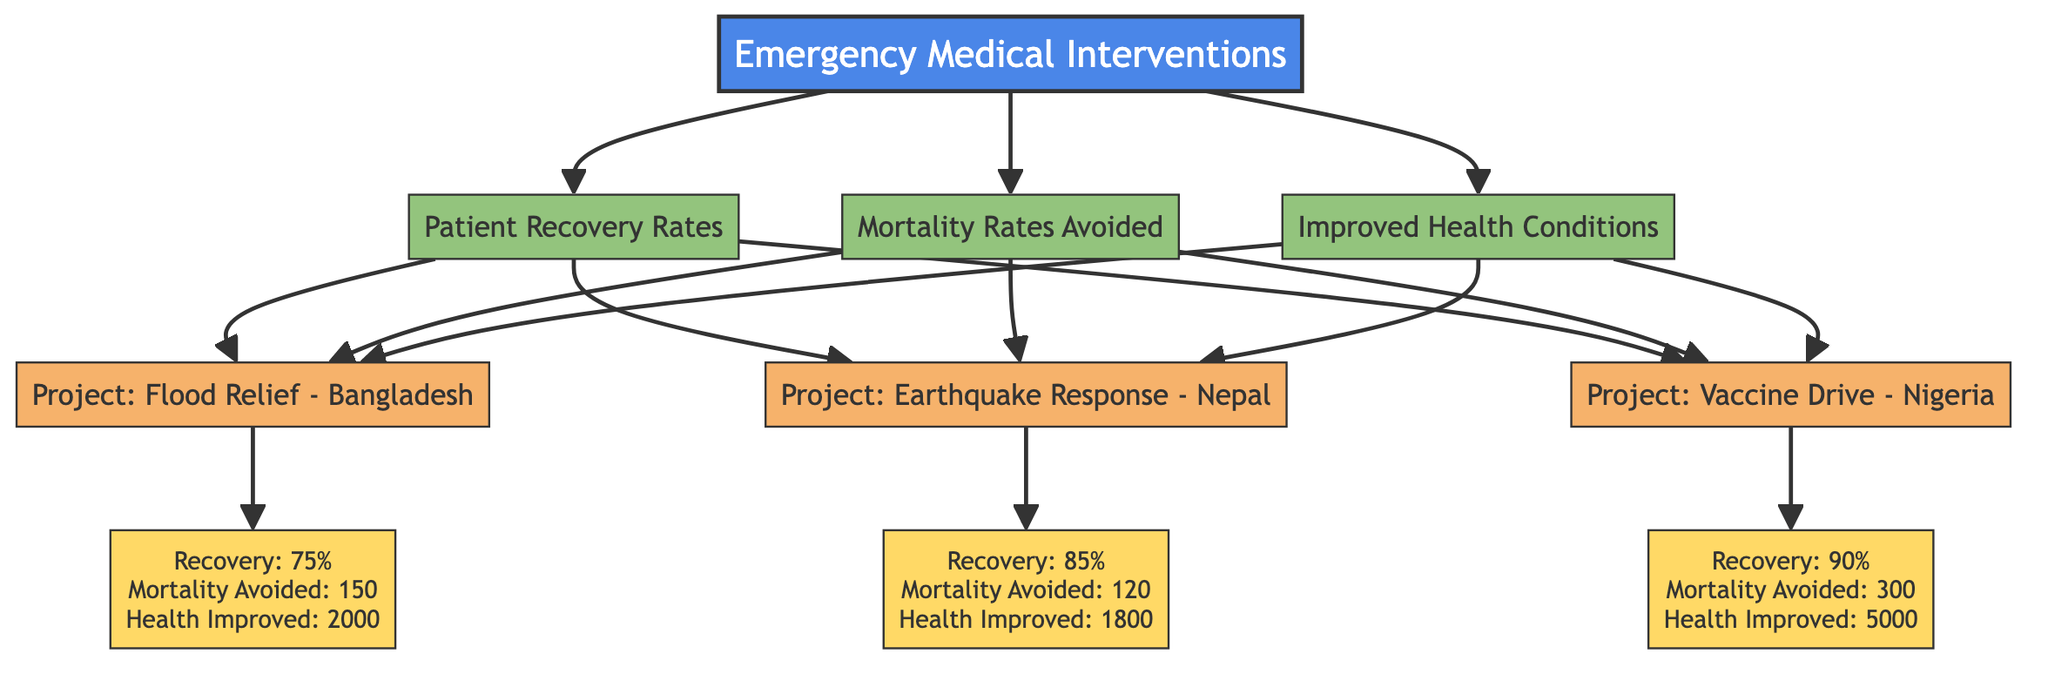What is the recovery rate for the Flood Relief project in Bangladesh? The diagram indicates that the recovery rate for the Flood Relief project in Bangladesh is 75%.
Answer: 75% How many health improvements were reported in the Vaccine Drive project in Nigeria? According to the data in the diagram, there were 5000 health improvements reported in the Vaccine Drive project in Nigeria.
Answer: 5000 What is the mortality rate avoided in the Earthquake Response project in Nepal? The diagram specifies that the mortality rate avoided in the Earthquake Response project in Nepal is 120.
Answer: 120 Which project has the highest patient recovery rate? By comparing the recovery rates indicated in the diagram, the Vaccine Drive project in Nigeria has the highest patient recovery rate at 90%.
Answer: Vaccine Drive - Nigeria How many total projects are represented in the diagram? The diagram depicts three projects: Flood Relief - Bangladesh, Earthquake Response - Nepal, and Vaccine Drive - Nigeria, totaling three projects.
Answer: 3 What is the relationship between patient recovery rates and mortality rates avoided for the Vaccine Drive project? The Vaccine Drive project shows a patient recovery rate of 90% alongside a mortality rate avoided of 300, establishing a positive correlation where higher recovery rates contribute to a significant avoided mortality rate.
Answer: Positive correlation If we sum the health improvements from all projects, what is the total? Health improvements from all projects are summed as follows: 2000 (Flood Relief) + 1800 (Earthquake Response) + 5000 (Vaccine Drive) = 8800 total health improvements across the projects.
Answer: 8800 Which project had the lowest mortality rates avoided? By examining the mortality rates avoided indicated in the diagram, the Earthquake Response project had the lowest mortality rate avoided at 120.
Answer: Earthquake Response - Nepal What is the average patient recovery rate across all projects? The average patient recovery rate can be calculated by adding the recovery rates (75% + 85% + 90%) and dividing by 3: (75 + 85 + 90) / 3 = 250 / 3 ≈ 83.33%.
Answer: 83.33% 